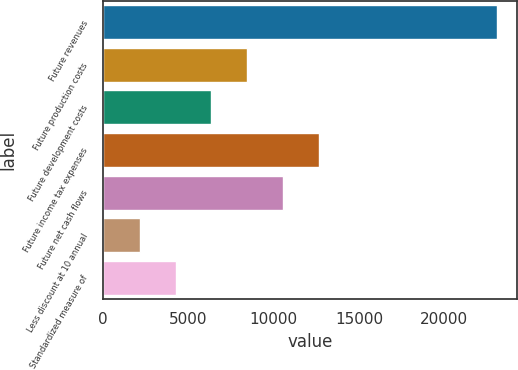Convert chart to OTSL. <chart><loc_0><loc_0><loc_500><loc_500><bar_chart><fcel>Future revenues<fcel>Future production costs<fcel>Future development costs<fcel>Future income tax expenses<fcel>Future net cash flows<fcel>Less discount at 10 annual<fcel>Standardized measure of<nl><fcel>23115<fcel>8443.7<fcel>6347.8<fcel>12635.5<fcel>10539.6<fcel>2156<fcel>4251.9<nl></chart> 